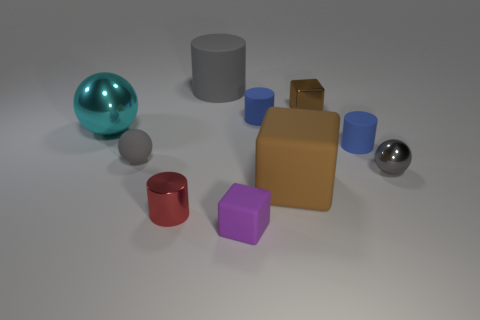Subtract all cylinders. How many objects are left? 6 Add 1 large rubber objects. How many large rubber objects are left? 3 Add 5 big brown metal cylinders. How many big brown metal cylinders exist? 5 Subtract 0 brown balls. How many objects are left? 10 Subtract all tiny brown metallic objects. Subtract all tiny purple rubber blocks. How many objects are left? 8 